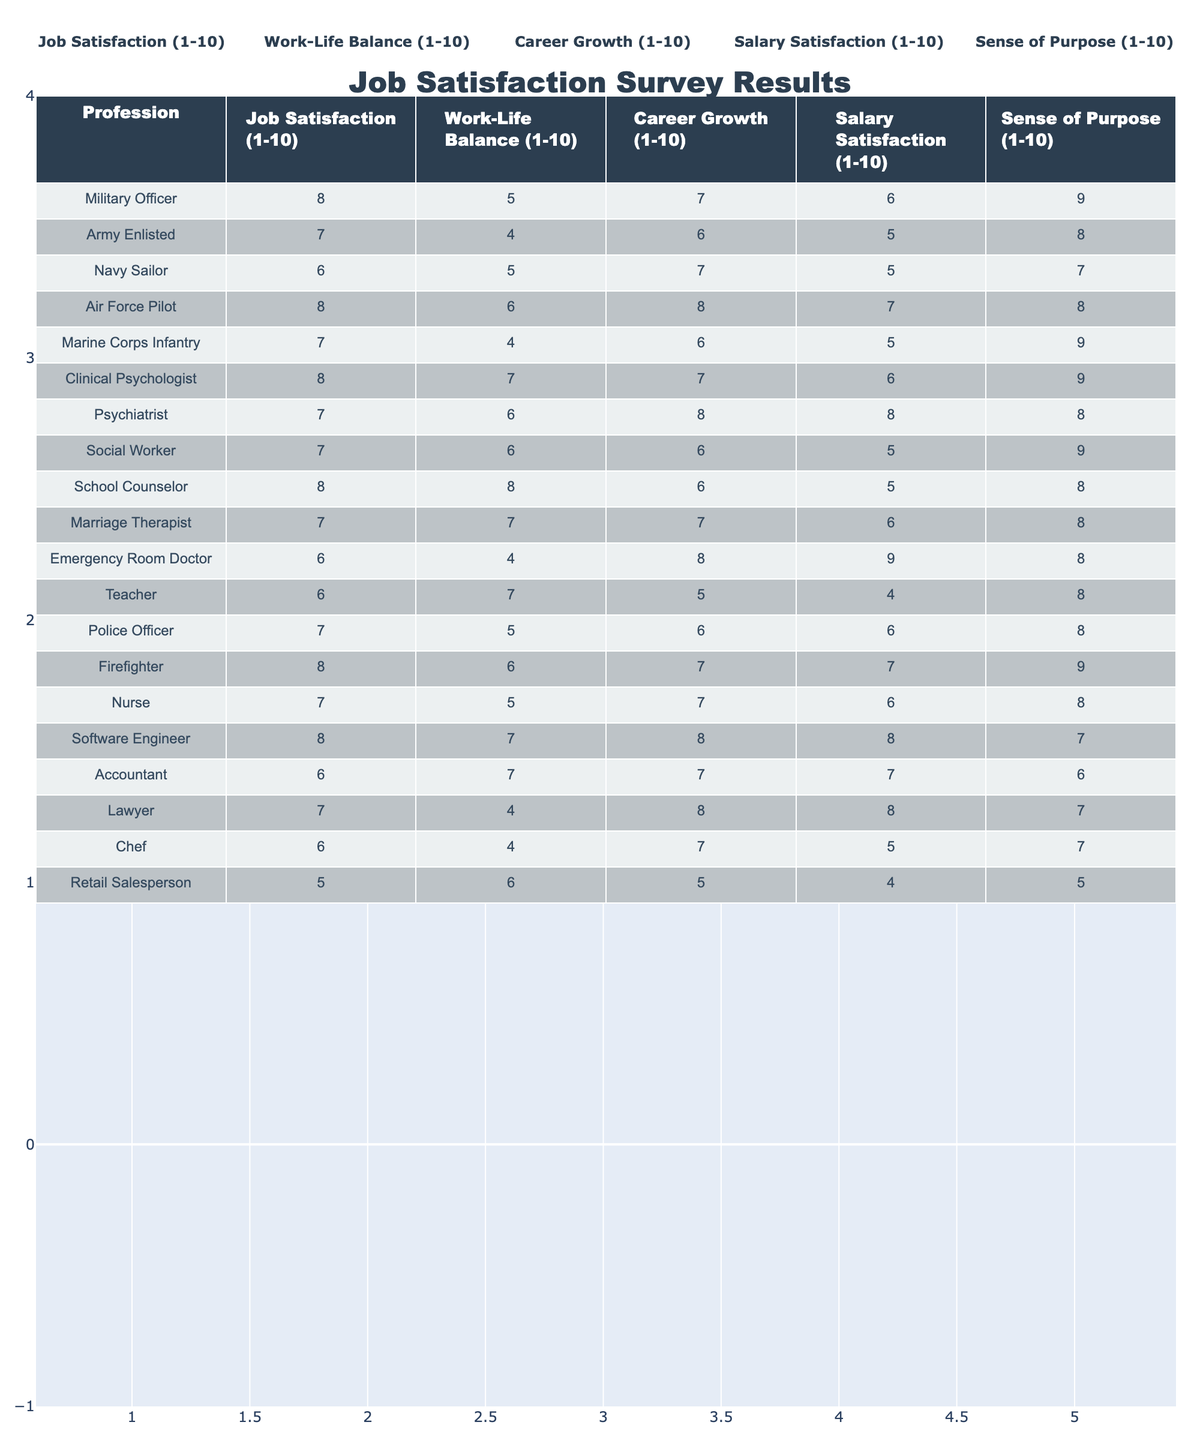What is the job satisfaction score for Clinical Psychologists? According to the table, the job satisfaction score for Clinical Psychologists is found in their row under the "Job Satisfaction (1-10)" column, which is 8.
Answer: 8 Which profession has the highest sense of purpose rating? By looking at the "Sense of Purpose (1-10)" column, I see that the professions with the highest rating of 9 are Military Officer, Marine Corps Infantry, Clinical Psychologist, and Firefighter.
Answer: Military Officer, Marine Corps Infantry, Clinical Psychologist, Firefighter What is the average work-life balance score for Military and Mental Health professionals? First, I extract the work-life balance scores for Military (5 for Military Officer, 4 for Army Enlisted, 5 for Navy Sailor, 6 for Air Force Pilot, 4 for Marine Corps Infantry) and Mental Health professionals (7 for Clinical Psychologist, 6 for Psychiatrist, 6 for Social Worker, 8 for School Counselor, 7 for Marriage Therapist). The scores sum up to 5+4+5+6+4 = 24 for Military professionals and 7+6+6+8+7 = 34 for Mental Health professionals. There are 5 Military and 5 Mental Health professionals, so the averages are 24/5 = 4.8 and 34/5 = 6.8 respectively.
Answer: Military: 4.8, Mental Health: 6.8 Is the job satisfaction score for firefighters higher than that of police officers? Checking the job satisfaction scores, Firefighters have a score of 8, while Police Officers have a score of 7. Since 8 is greater than 7, the answer is true.
Answer: Yes Which profession has the lowest salary satisfaction score? The table shows the salary satisfaction scores in the "Salary Satisfaction (1-10)" column. The Retail Salesperson has the lowest score of 4.
Answer: Retail Salesperson Calculate the difference in career growth scores between Air Force Pilots and Emergency Room Doctors. The career growth scores are 8 for Air Force Pilots and 8 for Emergency Room Doctors. The difference is calculated as 8 - 8 = 0.
Answer: 0 How many professions scored a 7 or above in Job Satisfaction? I review the "Job Satisfaction (1-10)" column and find the professions with scores of 7 or above: Military Officer, Army Enlisted, Air Force Pilot, Clinical Psychologist, School Counselor, Marriage Therapist, Firefighter, Software Engineer, and Lawyer, totaling 9 professions.
Answer: 9 Are all professions in the mental health field rated equally in terms of salary satisfaction? The salary satisfaction scores for the mental health professions show some variation: Clinical Psychologist and Marriage Therapist both scored 6, Psychiatrist scored 8, Social Worker scored 5, and School Counselor scored 5. Since there are differences, the answer is no.
Answer: No What is the overall average job satisfaction score from all professions listed? To find the overall average, I sum all job satisfaction scores: 8 + 7 + 6 + 8 + 7 + 8 + 7 + 8 + 7 + 6 + 6 + 7 + 8 + 7 + 5 = 111. There are 15 professions, so the average is 111/15 = 7.4.
Answer: 7.4 Which profession has the best work-life balance according to the survey results? Scanning the "Work-Life Balance (1-10)" column, School Counselor has the highest score of 8, indicating the best work-life balance among the listed professions.
Answer: School Counselor 